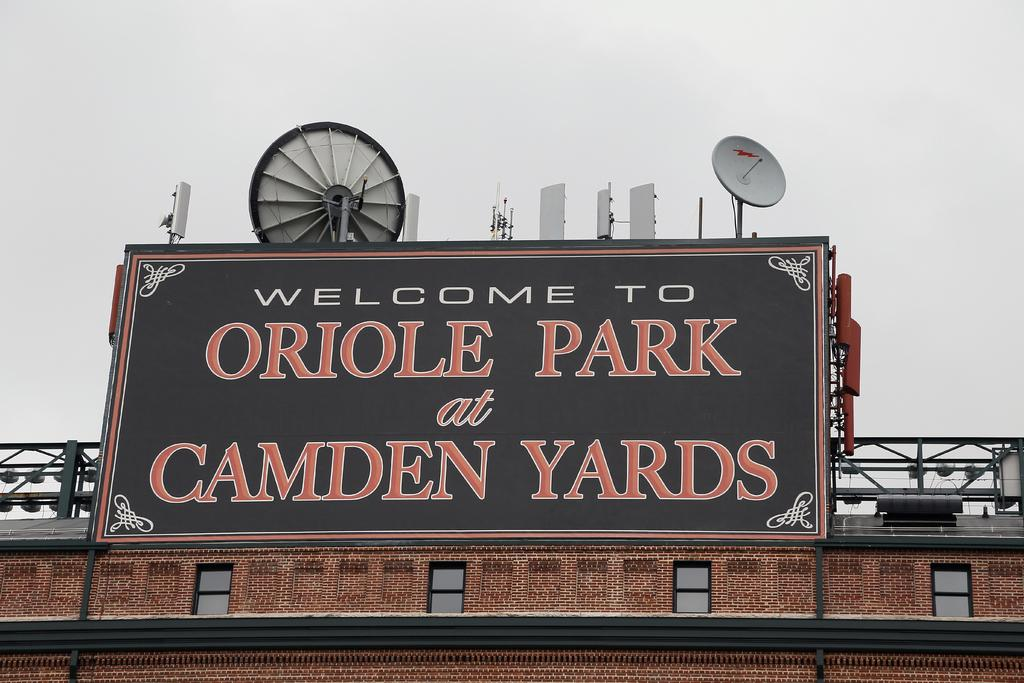<image>
Present a compact description of the photo's key features. a large sign on a building that reads welcom to oriole park at camden yards. 